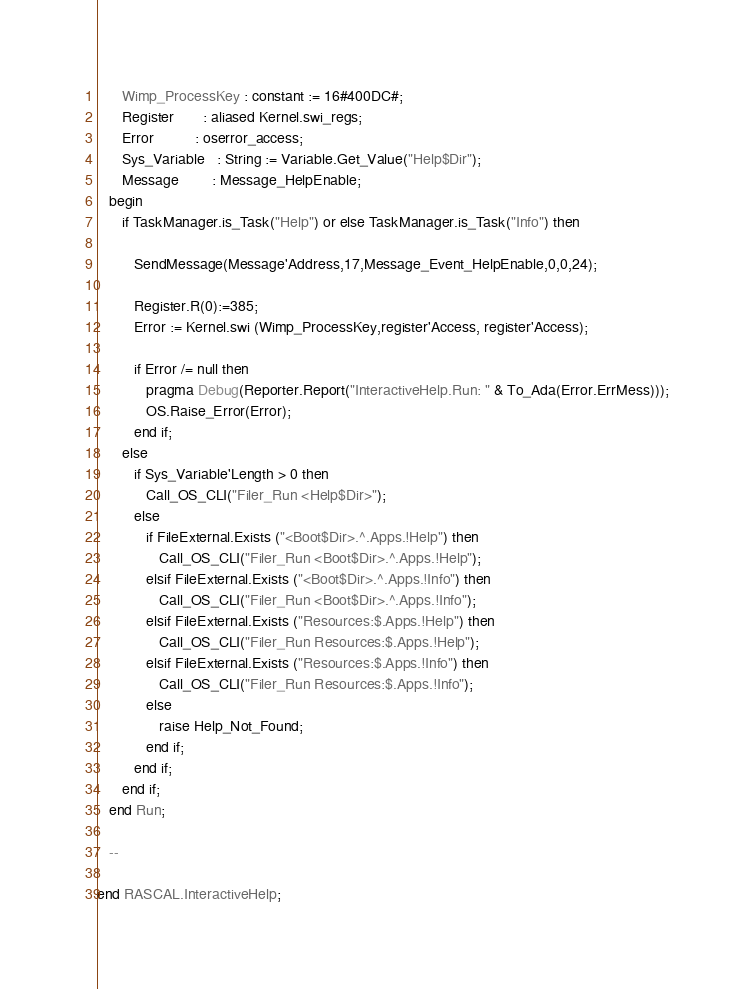Convert code to text. <code><loc_0><loc_0><loc_500><loc_500><_Ada_>      Wimp_ProcessKey : constant := 16#400DC#;
      Register       : aliased Kernel.swi_regs;
      Error          : oserror_access;
      Sys_Variable   : String := Variable.Get_Value("Help$Dir");
      Message        : Message_HelpEnable;
   begin
      if TaskManager.is_Task("Help") or else TaskManager.is_Task("Info") then

         SendMessage(Message'Address,17,Message_Event_HelpEnable,0,0,24);

         Register.R(0):=385;
         Error := Kernel.swi (Wimp_ProcessKey,register'Access, register'Access);

         if Error /= null then
            pragma Debug(Reporter.Report("InteractiveHelp.Run: " & To_Ada(Error.ErrMess)));
            OS.Raise_Error(Error);
         end if;
      else
         if Sys_Variable'Length > 0 then
            Call_OS_CLI("Filer_Run <Help$Dir>");
         else
            if FileExternal.Exists ("<Boot$Dir>.^.Apps.!Help") then
               Call_OS_CLI("Filer_Run <Boot$Dir>.^.Apps.!Help");
            elsif FileExternal.Exists ("<Boot$Dir>.^.Apps.!Info") then
               Call_OS_CLI("Filer_Run <Boot$Dir>.^.Apps.!Info");
            elsif FileExternal.Exists ("Resources:$.Apps.!Help") then
               Call_OS_CLI("Filer_Run Resources:$.Apps.!Help");
            elsif FileExternal.Exists ("Resources:$.Apps.!Info") then
               Call_OS_CLI("Filer_Run Resources:$.Apps.!Info");
            else
               raise Help_Not_Found;
            end if;
         end if;
      end if;
   end Run;

   --

end RASCAL.InteractiveHelp;
</code> 